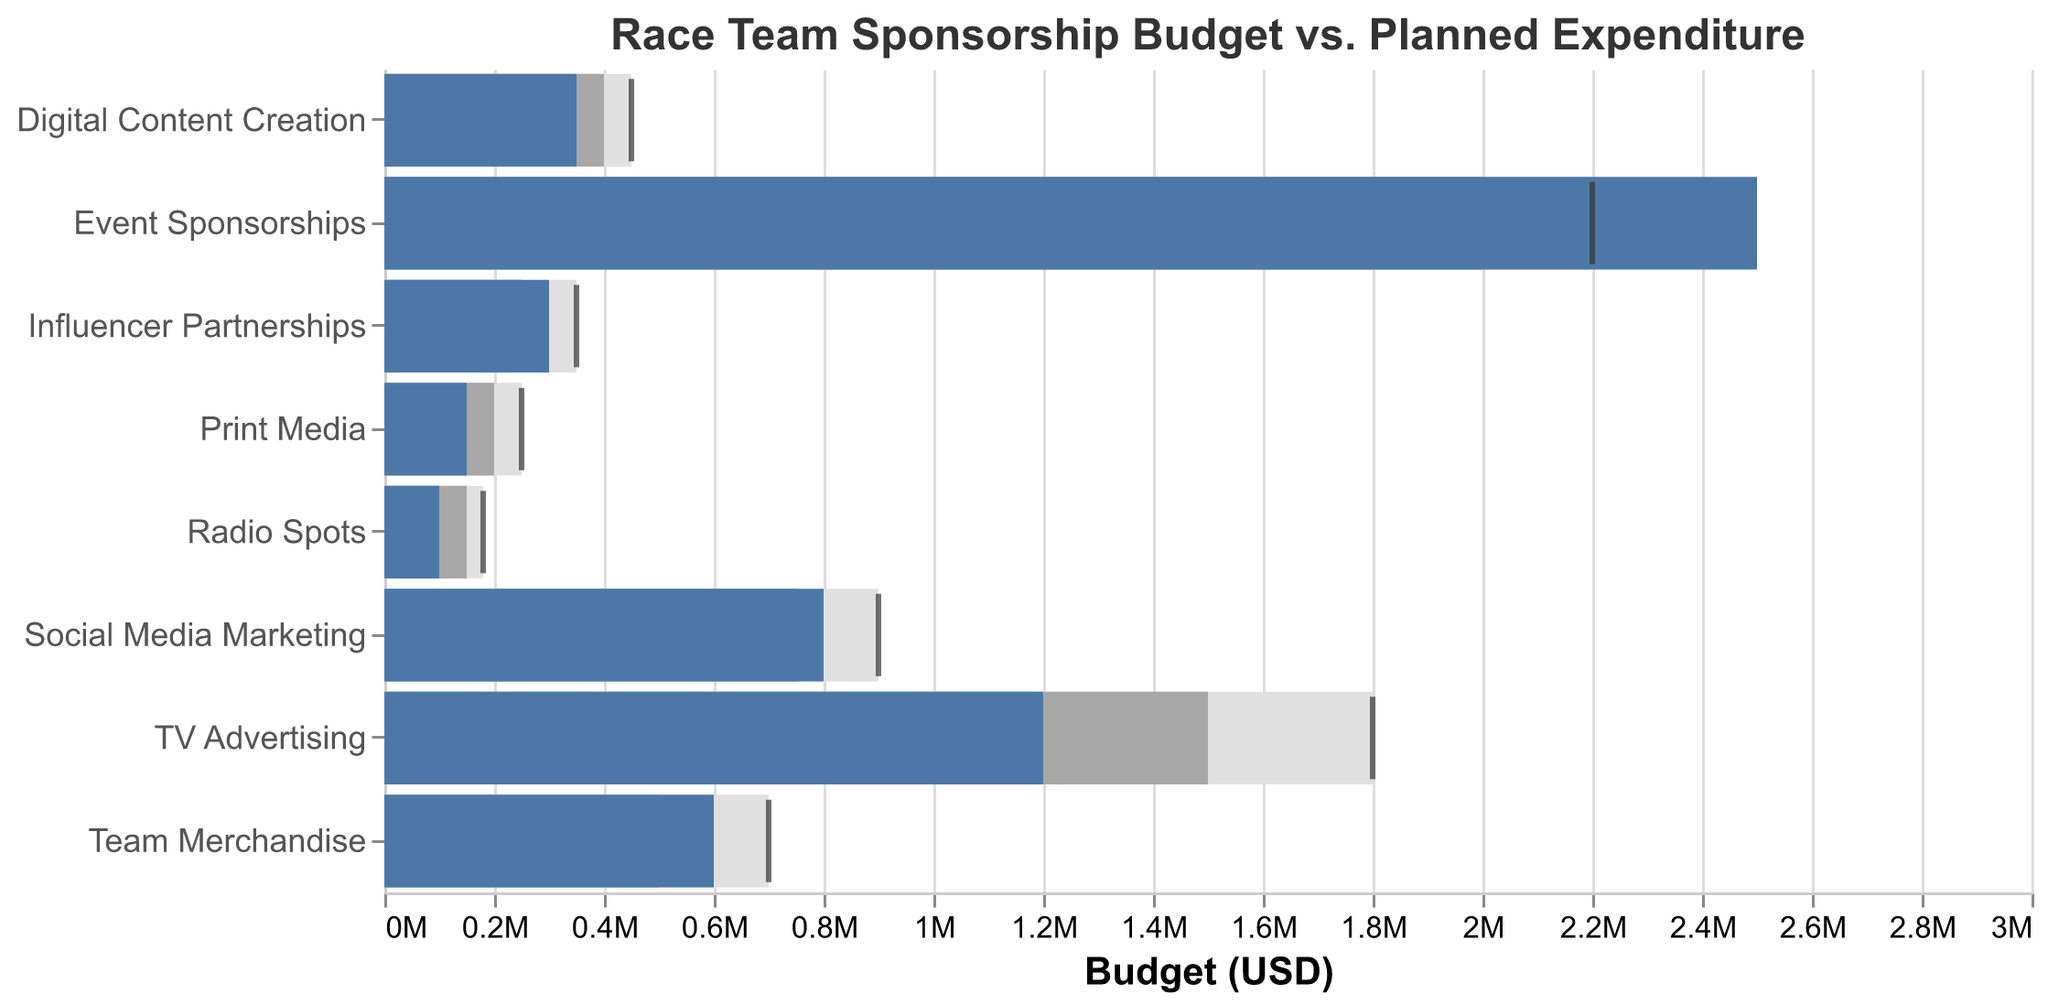What is the title of the chart? The title of the chart is usually located at the top of the visualization and provides a summary of the figure's content. In this chart, it reads "Race Team Sponsorship Budget vs. Planned Expenditure."
Answer: Race Team Sponsorship Budget vs. Planned Expenditure Which category has the highest actual expenditure? To find this, you need to compare the actual expenditure bars for all categories. "Event Sponsorships" has the longest bar under the "Actual" column.
Answer: Event Sponsorships How much more was spent on Team Merchandise compared to its planned budget? Find the actual expenditure for Team Merchandise (600,000) and subtract the planned budget (500,000). The calculation is 600,000 - 500,000.
Answer: 100,000 Which category was under its planned budget the most? By comparing the lengths of the bars in the "Planned" and "Actual" columns, "Print Media" shows the largest gap where actual expenditure (150,000) is significantly below the planned budget (200,000).
Answer: Print Media What is the sum of the actual expenditures for all the categories? Sum up all actual expenditures: 1,200,000 (TV Advertising) + 800,000 (Social Media Marketing) + 2,500,000 (Event Sponsorships) + 600,000 (Team Merchandise) + 350,000 (Digital Content Creation) + 150,000 (Print Media) + 100,000 (Radio Spots) + 300,000 (Influencer Partnerships). The total is 6,000,000.
Answer: 6,000,000 How does the actual expenditure for Social Media Marketing compare to its target? Look at the "Actual" bar for Social Media Marketing (800,000) and compare it to the "Target" tick (900,000). The actual expenditure is 100,000 less than the target.
Answer: 100,000 less Which category has a planned budget closest to its target? To find this, compare the planned budget and target values for each category. "Social Media Marketing" has the closest figures: Planned (750,000) and Target (900,000). The difference is 150,000, which is closer compared to other gaps in different categories.
Answer: Social Media Marketing By how much does the actual expenditure for Radio Spots fall short of its target? Subtract the actual expenditure for Radio Spots (100,000) from its target (180,000). The calculation is 180,000 - 100,000.
Answer: 80,000 Which marketing channel exceeded both its planned and target budget? Compare the actual expenditures against both planned and target budget numbers. None of the categories exceed both their planned and target budgets based on the provided data.
Answer: None 